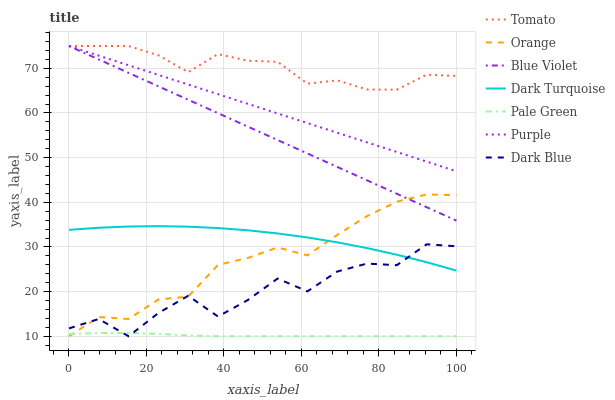Does Pale Green have the minimum area under the curve?
Answer yes or no. Yes. Does Tomato have the maximum area under the curve?
Answer yes or no. Yes. Does Purple have the minimum area under the curve?
Answer yes or no. No. Does Purple have the maximum area under the curve?
Answer yes or no. No. Is Blue Violet the smoothest?
Answer yes or no. Yes. Is Dark Blue the roughest?
Answer yes or no. Yes. Is Purple the smoothest?
Answer yes or no. No. Is Purple the roughest?
Answer yes or no. No. Does Purple have the lowest value?
Answer yes or no. No. Does Dark Turquoise have the highest value?
Answer yes or no. No. Is Pale Green less than Purple?
Answer yes or no. Yes. Is Purple greater than Pale Green?
Answer yes or no. Yes. Does Pale Green intersect Purple?
Answer yes or no. No. 